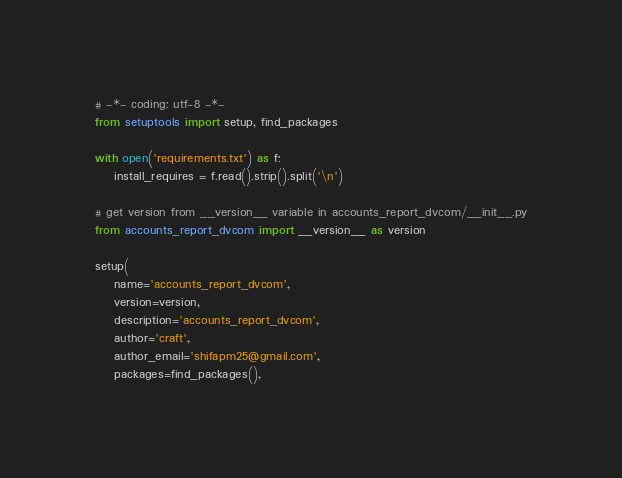<code> <loc_0><loc_0><loc_500><loc_500><_Python_># -*- coding: utf-8 -*-
from setuptools import setup, find_packages

with open('requirements.txt') as f:
	install_requires = f.read().strip().split('\n')

# get version from __version__ variable in accounts_report_dvcom/__init__.py
from accounts_report_dvcom import __version__ as version

setup(
	name='accounts_report_dvcom',
	version=version,
	description='accounts_report_dvcom',
	author='craft',
	author_email='shifapm25@gmail.com',
	packages=find_packages(),</code> 